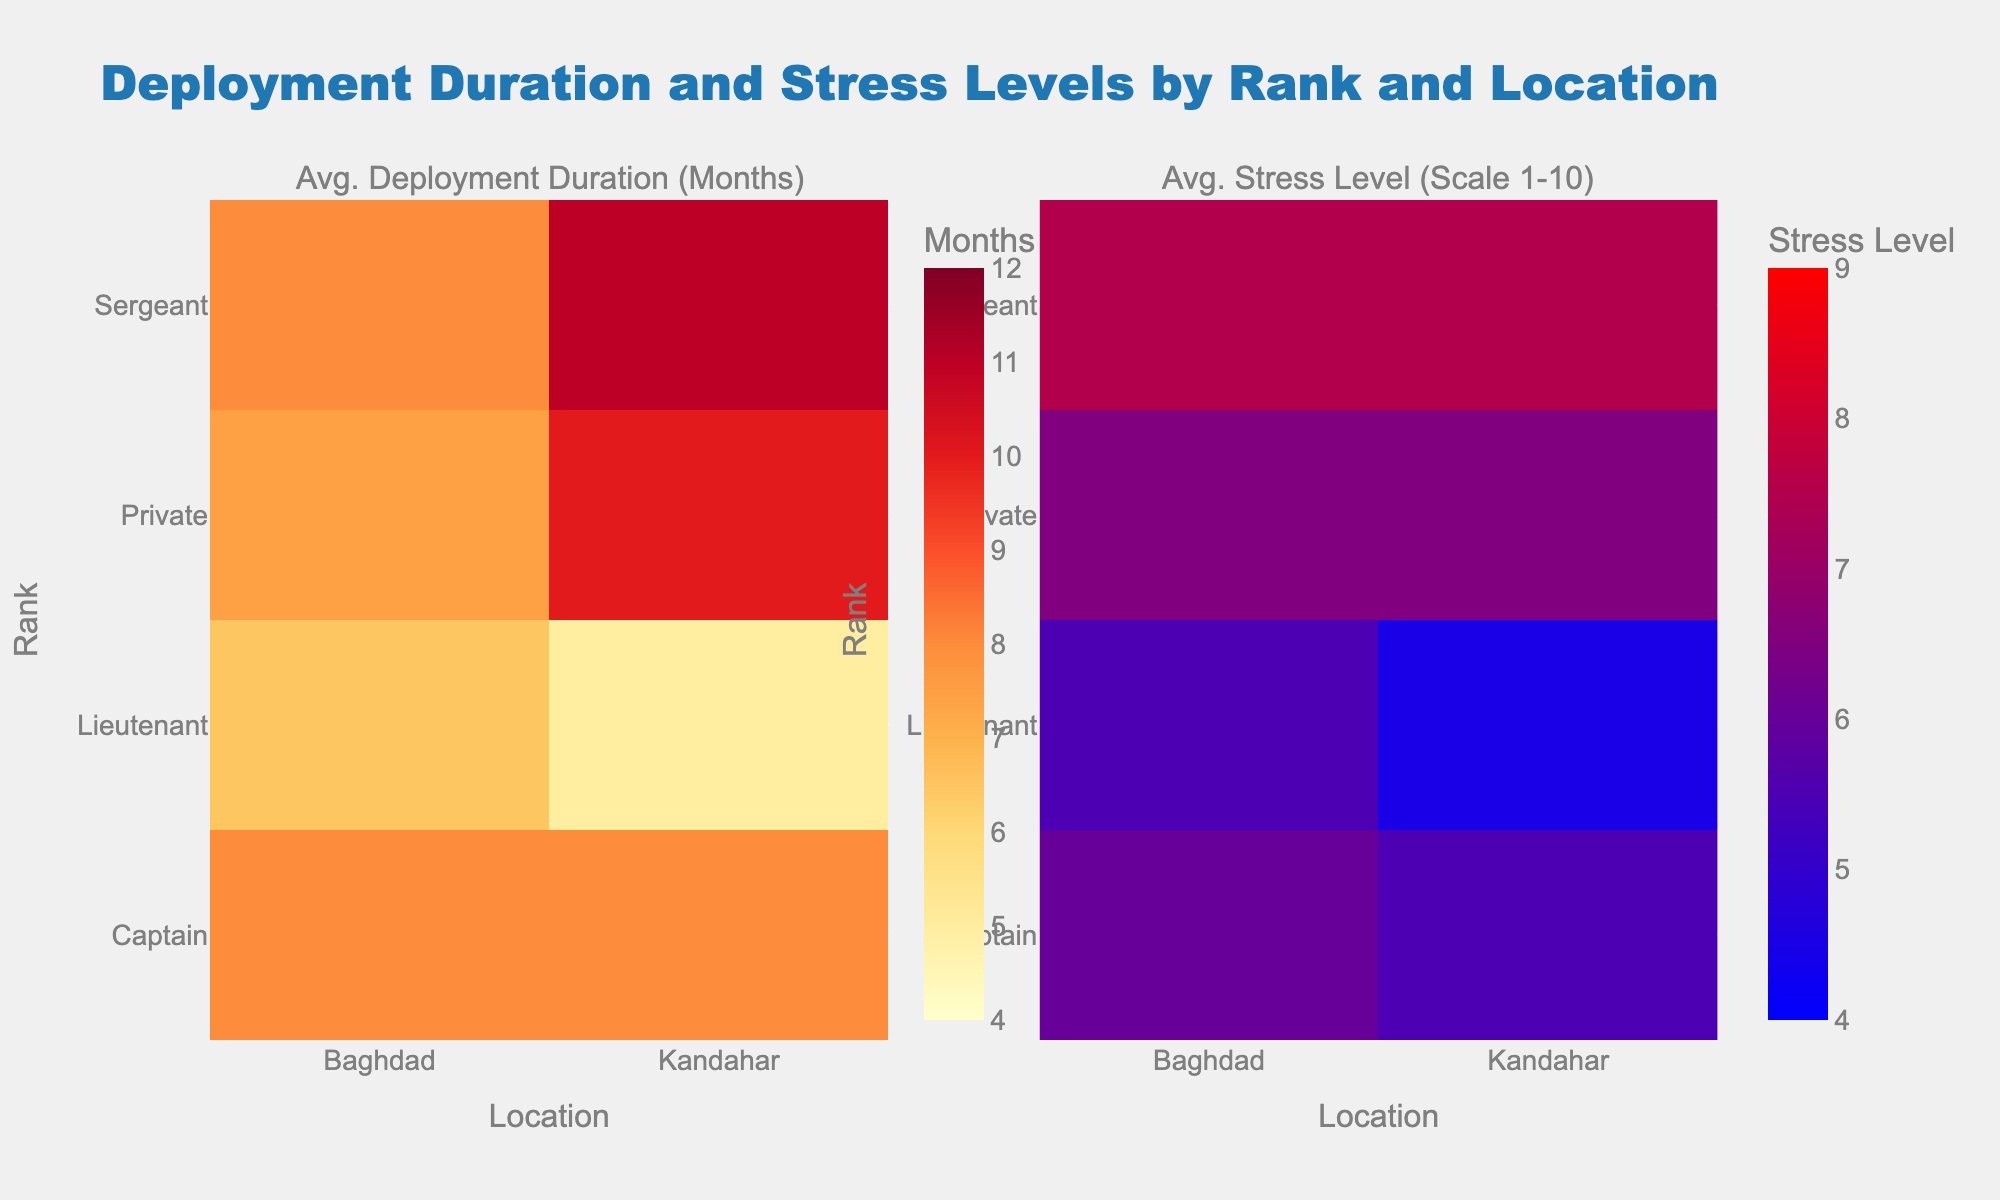What is the title of this figure? The title is typically displayed prominently at the top of the figure.
Answer: Deployment Duration and Stress Levels by Rank and Location How many subplots are in this figure? We can see two distinct sections, each with a different title, indicating multiple subplots.
Answer: 2 Which rank and location combination has the highest average deployment duration? Identify the darkest cell within the first heatmap, as darker colors indicate higher values.
Answer: Private, Kandahar What is the average stress level for Captains in Baghdad? Locate the cell corresponding to Captains and Baghdad on the second heatmap.
Answer: 7 How do the deployment durations for Sergeants differ between Kandahar and Baghdad? Compare the color intensities in the first heatmap for Sergeants in both locations.
Answer: Kandahar: 11, Baghdad: 8 What is the average deployment duration for Lieutenants in Kandahar? Locate the cell corresponding to Lieutenants and Kandahar in the first heatmap.
Answer: 5 Which location generally shows higher stress levels for Privates, Kandahar or Baghdad? On the second heatmap, compare the color intensity for Privates in both locations.
Answer: Baghdad How does the stress level for Sergeants in Baghdad compare with that of Captains in Kandahar? Compare the color intensities in the second heatmap: Sergeants in Baghdad vs. Captains in Kandahar.
Answer: Higher What is the overall difference in average stress levels between Kandahar and Baghdad for all ranks? Calculate the average stress level for all ranks in both locations and find the difference.
Answer: Kandahar: 6.5, Baghdad: 6.5, Difference: 0 By how much does the average deployment duration for Captains in Baghdad exceed that of Lieutenants in the same location? Subtract the average deployment duration of Lieutenants from that of Captains for Baghdad on the first heatmap.
Answer: 2 